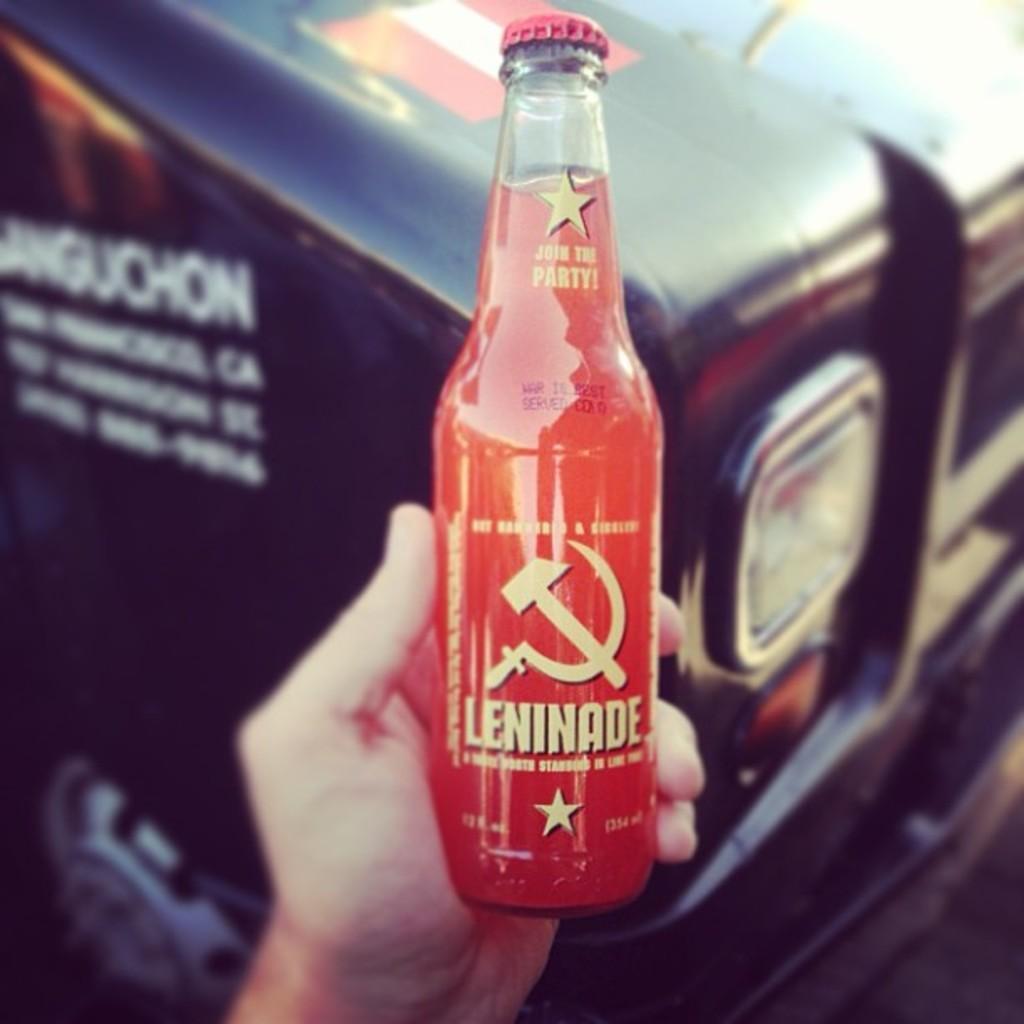In one or two sentences, can you explain what this image depicts? In this picture there is a juice bottle which contains juice in it, and there is a hand by holding the bottle in the image the is word leninade written on the bottle. 